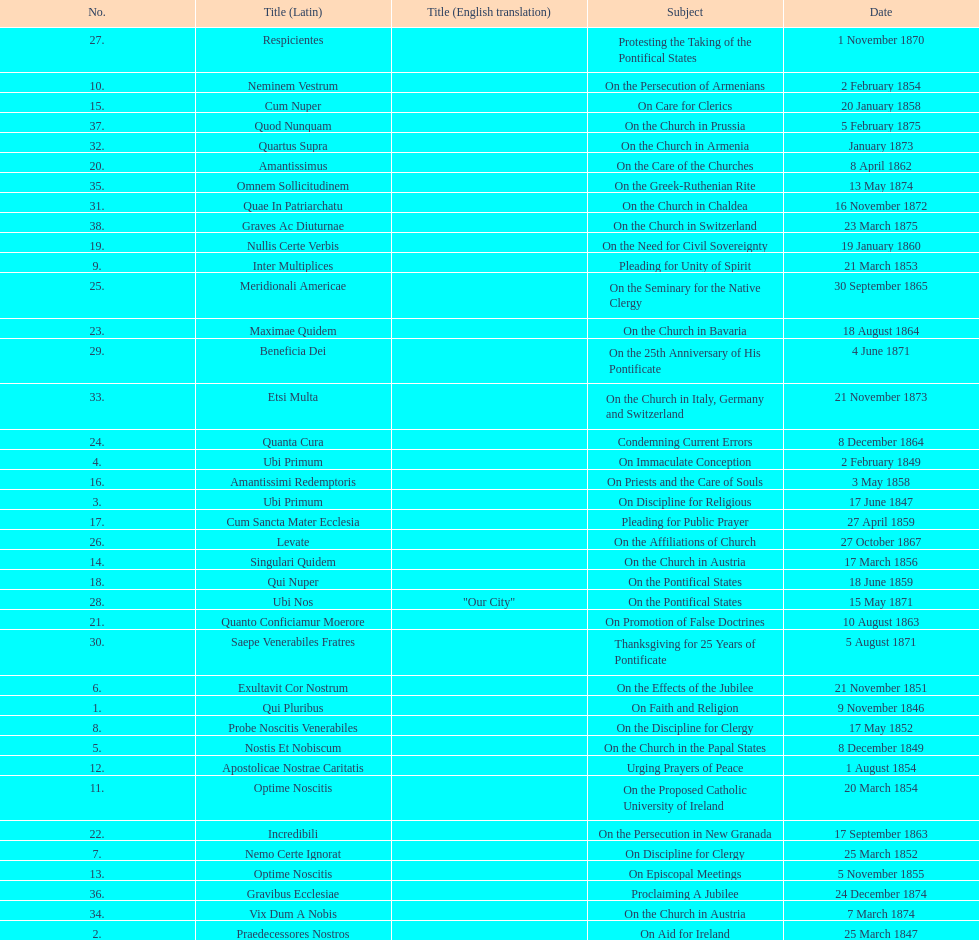When did the latest encyclical discussing a theme with the word "pontificate" occur? 5 August 1871. 